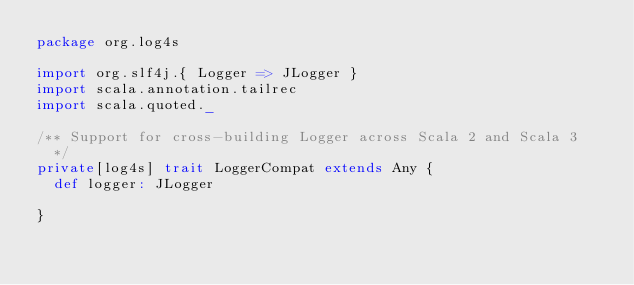<code> <loc_0><loc_0><loc_500><loc_500><_Scala_>package org.log4s

import org.slf4j.{ Logger => JLogger }
import scala.annotation.tailrec
import scala.quoted._

/** Support for cross-building Logger across Scala 2 and Scala 3
  */
private[log4s] trait LoggerCompat extends Any {
  def logger: JLogger

}
</code> 